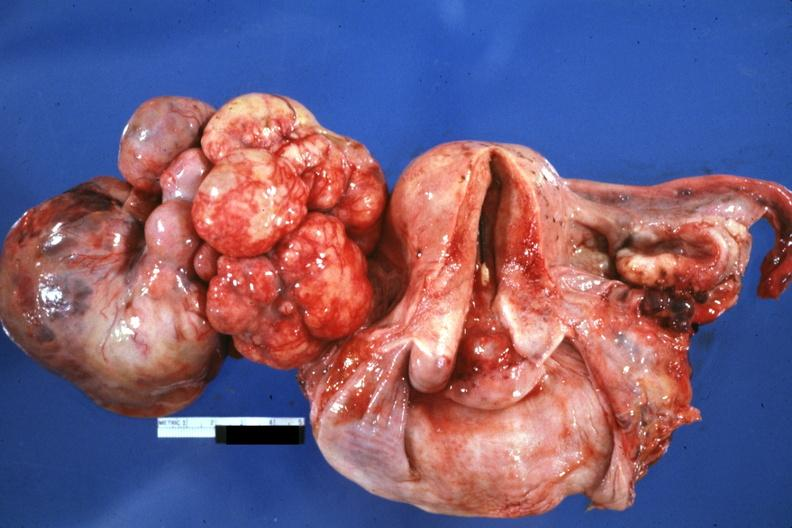s intraductal papillomatosis with apocrine metaplasia present?
Answer the question using a single word or phrase. No 